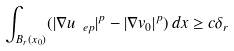Convert formula to latex. <formula><loc_0><loc_0><loc_500><loc_500>\int _ { B _ { r } ( x _ { 0 } ) } ( | \nabla u _ { \ e p } | ^ { p } - | \nabla v _ { 0 } | ^ { p } ) \, d x \geq c \delta _ { r }</formula> 